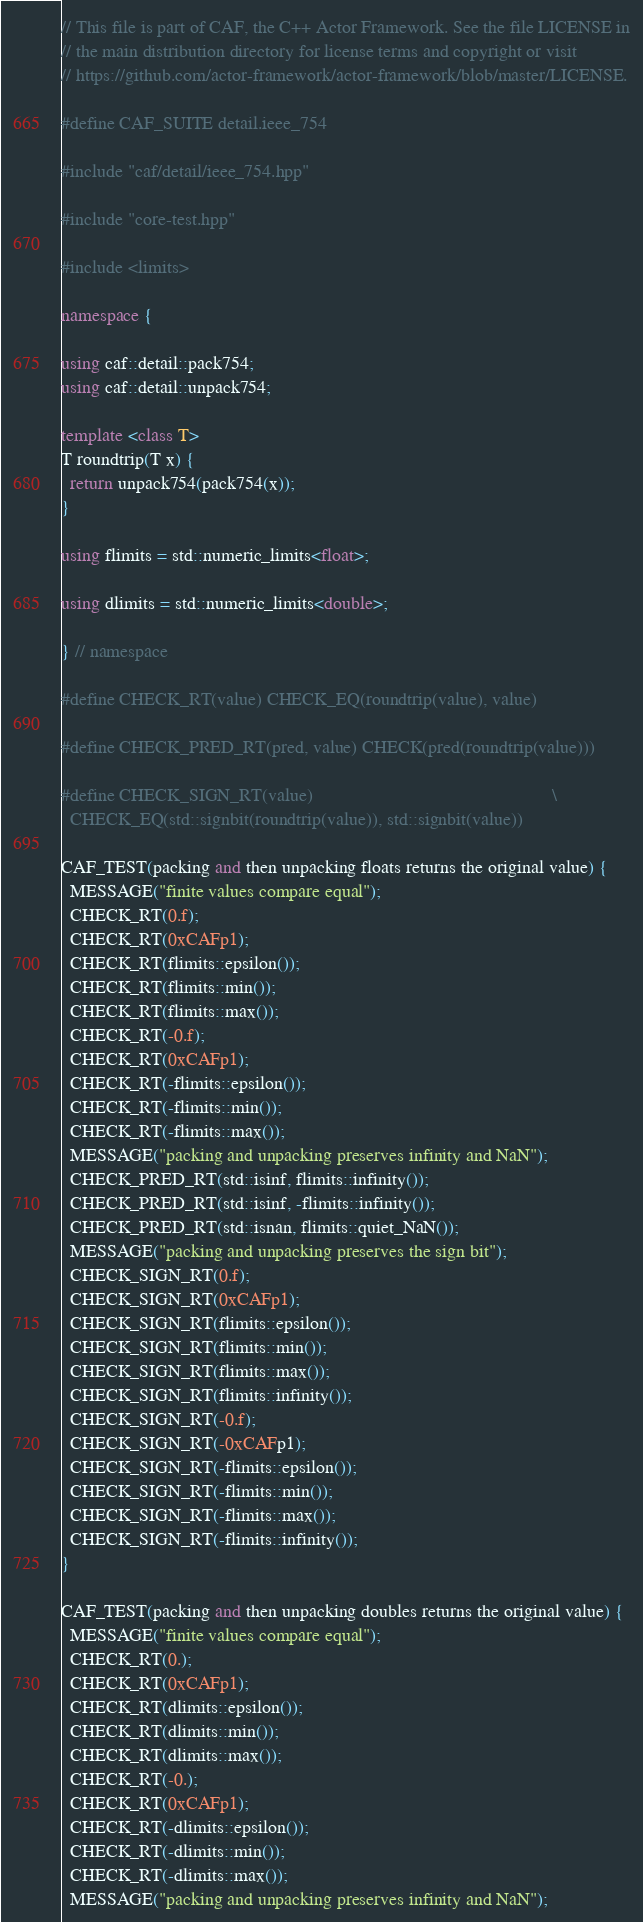<code> <loc_0><loc_0><loc_500><loc_500><_C++_>// This file is part of CAF, the C++ Actor Framework. See the file LICENSE in
// the main distribution directory for license terms and copyright or visit
// https://github.com/actor-framework/actor-framework/blob/master/LICENSE.

#define CAF_SUITE detail.ieee_754

#include "caf/detail/ieee_754.hpp"

#include "core-test.hpp"

#include <limits>

namespace {

using caf::detail::pack754;
using caf::detail::unpack754;

template <class T>
T roundtrip(T x) {
  return unpack754(pack754(x));
}

using flimits = std::numeric_limits<float>;

using dlimits = std::numeric_limits<double>;

} // namespace

#define CHECK_RT(value) CHECK_EQ(roundtrip(value), value)

#define CHECK_PRED_RT(pred, value) CHECK(pred(roundtrip(value)))

#define CHECK_SIGN_RT(value)                                                   \
  CHECK_EQ(std::signbit(roundtrip(value)), std::signbit(value))

CAF_TEST(packing and then unpacking floats returns the original value) {
  MESSAGE("finite values compare equal");
  CHECK_RT(0.f);
  CHECK_RT(0xCAFp1);
  CHECK_RT(flimits::epsilon());
  CHECK_RT(flimits::min());
  CHECK_RT(flimits::max());
  CHECK_RT(-0.f);
  CHECK_RT(0xCAFp1);
  CHECK_RT(-flimits::epsilon());
  CHECK_RT(-flimits::min());
  CHECK_RT(-flimits::max());
  MESSAGE("packing and unpacking preserves infinity and NaN");
  CHECK_PRED_RT(std::isinf, flimits::infinity());
  CHECK_PRED_RT(std::isinf, -flimits::infinity());
  CHECK_PRED_RT(std::isnan, flimits::quiet_NaN());
  MESSAGE("packing and unpacking preserves the sign bit");
  CHECK_SIGN_RT(0.f);
  CHECK_SIGN_RT(0xCAFp1);
  CHECK_SIGN_RT(flimits::epsilon());
  CHECK_SIGN_RT(flimits::min());
  CHECK_SIGN_RT(flimits::max());
  CHECK_SIGN_RT(flimits::infinity());
  CHECK_SIGN_RT(-0.f);
  CHECK_SIGN_RT(-0xCAFp1);
  CHECK_SIGN_RT(-flimits::epsilon());
  CHECK_SIGN_RT(-flimits::min());
  CHECK_SIGN_RT(-flimits::max());
  CHECK_SIGN_RT(-flimits::infinity());
}

CAF_TEST(packing and then unpacking doubles returns the original value) {
  MESSAGE("finite values compare equal");
  CHECK_RT(0.);
  CHECK_RT(0xCAFp1);
  CHECK_RT(dlimits::epsilon());
  CHECK_RT(dlimits::min());
  CHECK_RT(dlimits::max());
  CHECK_RT(-0.);
  CHECK_RT(0xCAFp1);
  CHECK_RT(-dlimits::epsilon());
  CHECK_RT(-dlimits::min());
  CHECK_RT(-dlimits::max());
  MESSAGE("packing and unpacking preserves infinity and NaN");</code> 